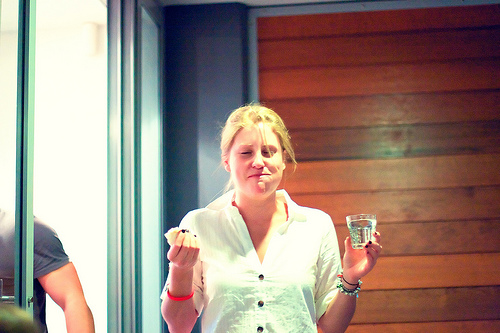<image>
Is there a glass in front of the wall? Yes. The glass is positioned in front of the wall, appearing closer to the camera viewpoint. Where is the woman in relation to the wood? Is it in front of the wood? Yes. The woman is positioned in front of the wood, appearing closer to the camera viewpoint. 